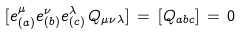<formula> <loc_0><loc_0><loc_500><loc_500>[ e _ { ( a ) } ^ { \mu } e _ { ( b ) } ^ { \nu } e _ { ( c ) } ^ { \lambda } \, Q _ { \mu \nu \lambda } ] \, = \, [ Q _ { a b c } ] \, = \, 0</formula> 